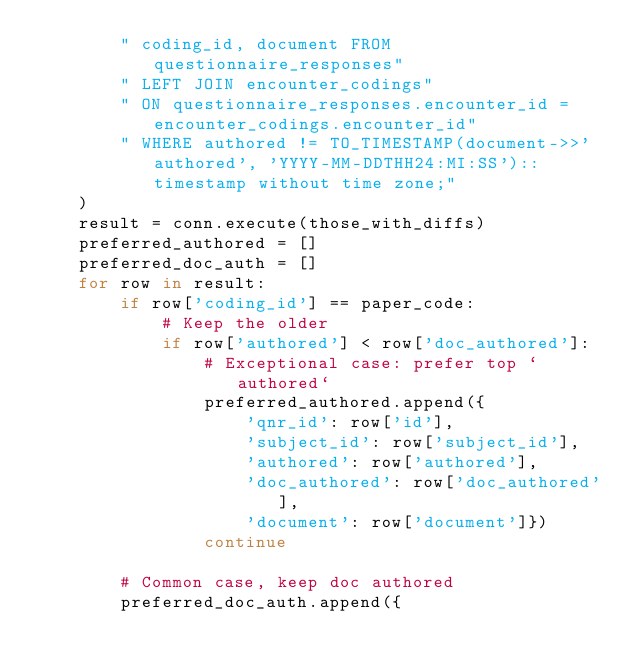<code> <loc_0><loc_0><loc_500><loc_500><_Python_>        " coding_id, document FROM questionnaire_responses"
        " LEFT JOIN encounter_codings"
        " ON questionnaire_responses.encounter_id = encounter_codings.encounter_id"
        " WHERE authored != TO_TIMESTAMP(document->>'authored', 'YYYY-MM-DDTHH24:MI:SS')::timestamp without time zone;"
    )
    result = conn.execute(those_with_diffs)
    preferred_authored = []
    preferred_doc_auth = []
    for row in result:
        if row['coding_id'] == paper_code:
            # Keep the older
            if row['authored'] < row['doc_authored']:
                # Exceptional case: prefer top `authored`
                preferred_authored.append({
                    'qnr_id': row['id'],
                    'subject_id': row['subject_id'],
                    'authored': row['authored'],
                    'doc_authored': row['doc_authored'],
                    'document': row['document']})
                continue

        # Common case, keep doc authored
        preferred_doc_auth.append({</code> 